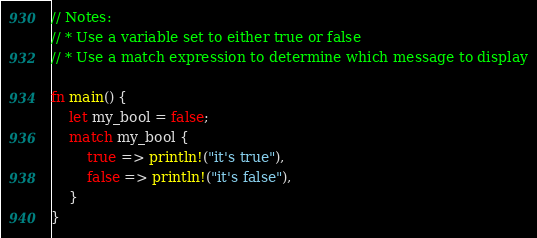Convert code to text. <code><loc_0><loc_0><loc_500><loc_500><_Rust_>// Notes:
// * Use a variable set to either true or false
// * Use a match expression to determine which message to display

fn main() {
    let my_bool = false;
    match my_bool {
        true => println!("it's true"),
        false => println!("it's false"),
    }
}
</code> 